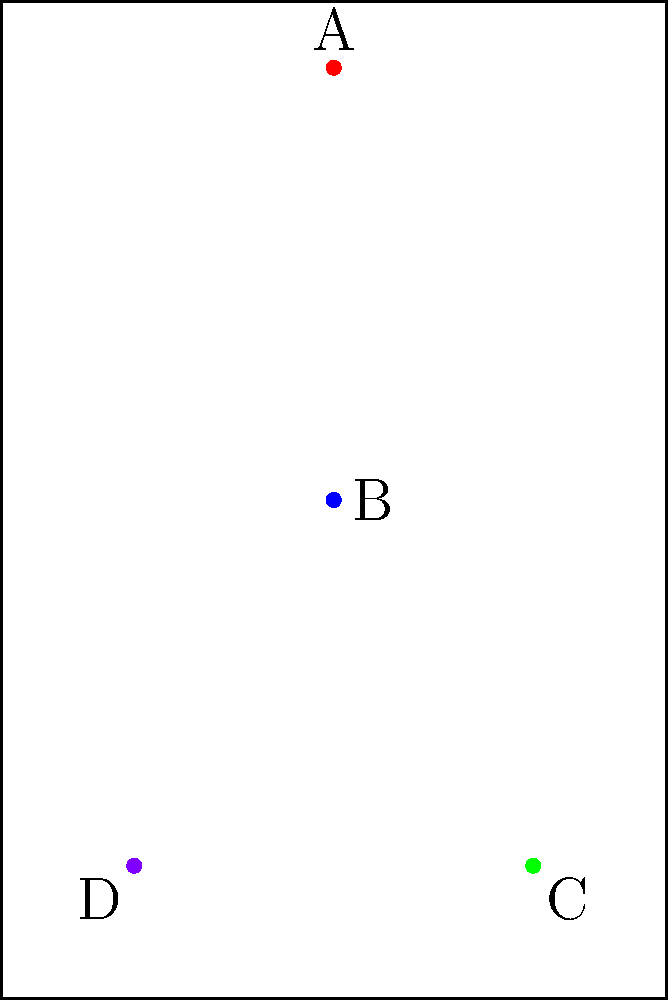In a traditional Japanese hanging scroll composition, which arrangement of elements is correct, from top to bottom? To answer this question, we need to understand the traditional layout of a Japanese hanging scroll (kakemono):

1. The topmost element is usually the title or subject of the calligraphy, represented by point A in the diagram.

2. Below the title, we find the main text or primary calligraphy, which is the largest and most prominent part of the composition. This is represented by point B.

3. Near the bottom right corner, we typically find the artist's name or signature, shown as point C in the diagram.

4. Finally, in the bottom left corner, the artist's seal is usually placed, represented by point D.

Therefore, the correct arrangement from top to bottom would be:

Title (A) → Main Text (B) → Artist's Name (C) → Seal (D)

This arrangement follows the traditional flow of a Japanese hanging scroll, allowing the viewer to appreciate the work in a logical and aesthetically pleasing manner.
Answer: A → B → C → D 